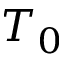Convert formula to latex. <formula><loc_0><loc_0><loc_500><loc_500>T _ { 0 }</formula> 